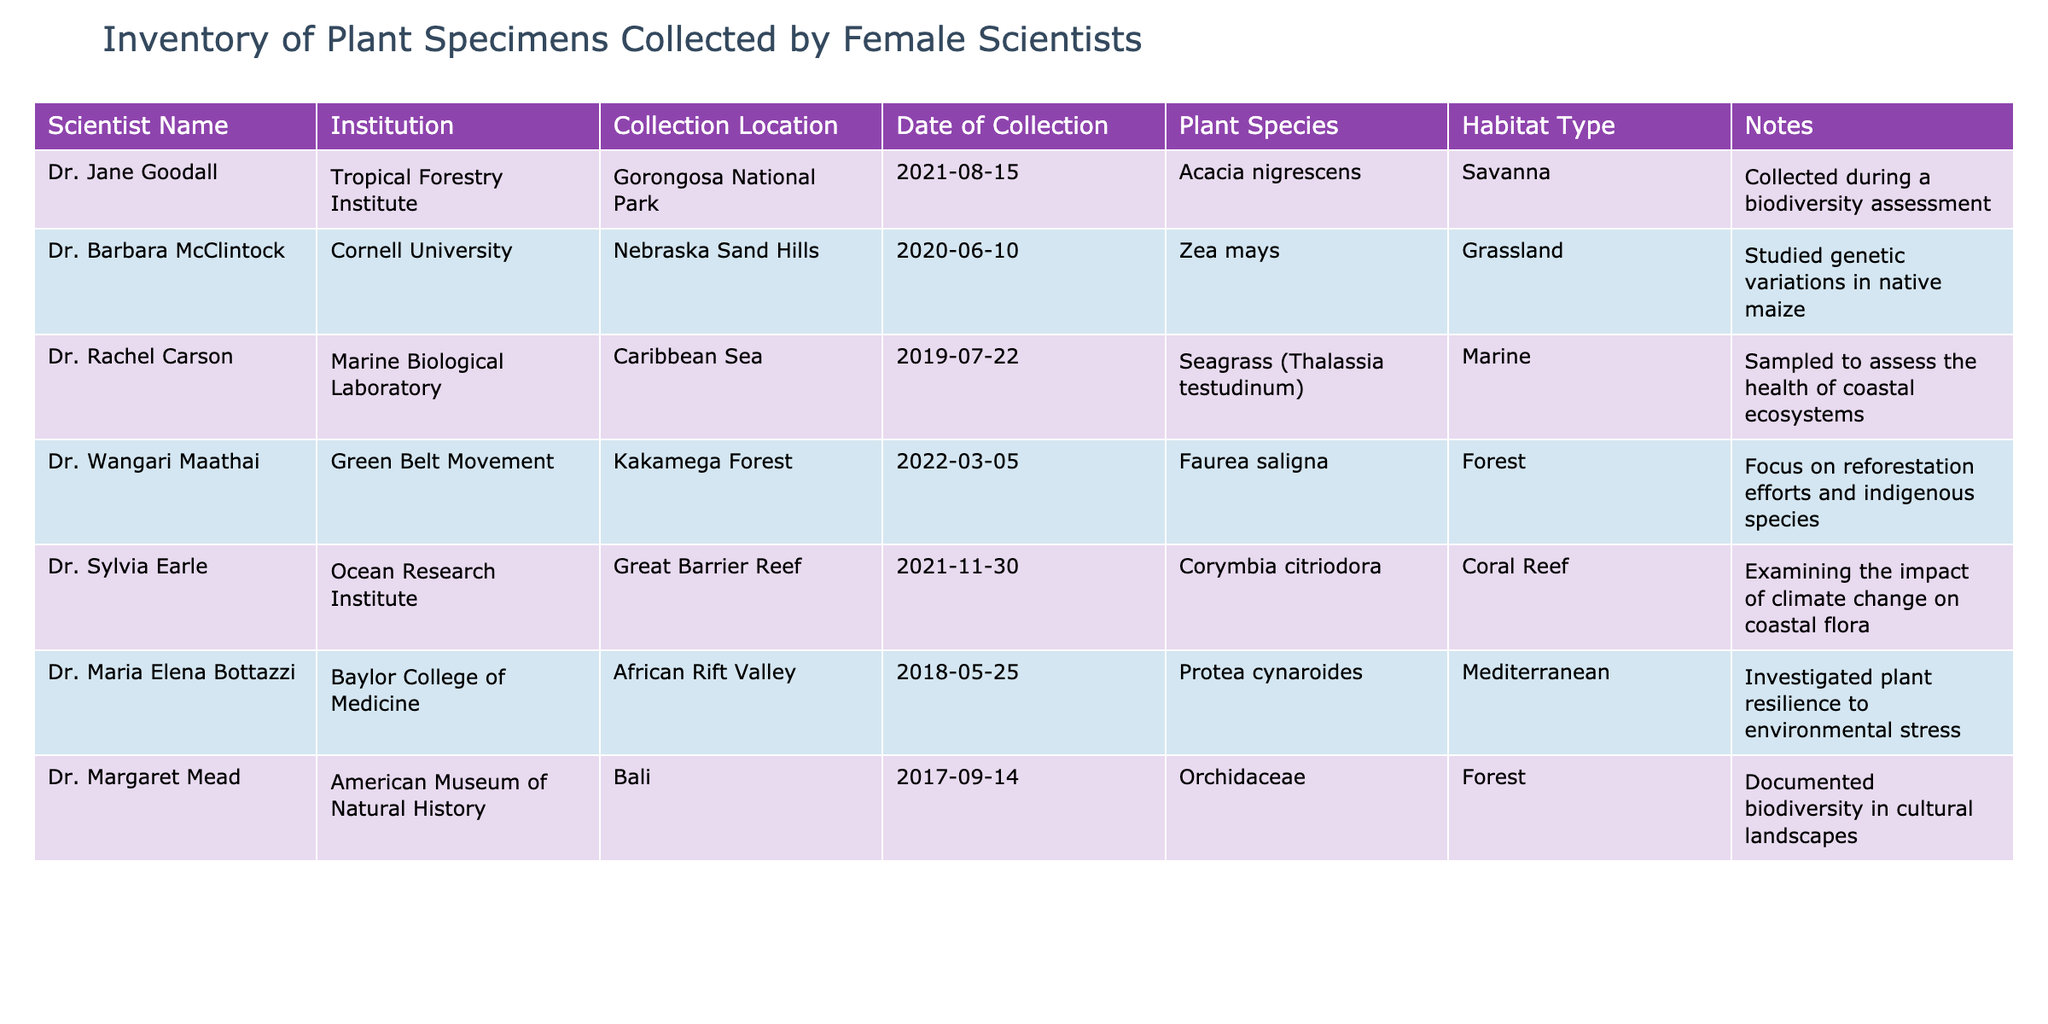What is the plant species collected by Dr. Rachel Carson? In the table, we can find Dr. Rachel Carson's entry, and it lists "Seagrass (Thalassia testudinum)" as the plant species she collected.
Answer: Seagrass (Thalassia testudinum) How many specimens were collected from forest habitats? By examining the "Habitat Type" column, we see that two entries are marked as "Forest": one from Dr. Wangari Maathai and another from Dr. Margaret Mead. Therefore, there are 2 specimens collected from forest habitats.
Answer: 2 Did Dr. Jane Goodall collect specimens in 2021? Looking at Dr. Jane Goodall's entry, the "Date of Collection" is listed as "2021-08-15", which confirms that she did collect specimens that year.
Answer: Yes Which scientist focused on climate change impact on coastal flora? Referring to the table, Dr. Sylvia Earle is the scientist who examined the impact of climate change on coastal flora, as indicated in her notes.
Answer: Dr. Sylvia Earle What is the total number of specimens collected in 2020? Checking the "Date of Collection" column, only Dr. Barbara McClintock's entry is from 2020. Since there is only one specimen from that year, the total is 1.
Answer: 1 Which collection location is associated with the plant species "Orchidaceae"? The entry for "Orchidaceae" associates it with the collection location "Bali" as stated in Dr. Margaret Mead's row in the table.
Answer: Bali What is the average year of collection for the specimens in this inventory? The years of collection span from 2017 to 2022. We can calculate the average year of collection by adding these years: (2017 + 2018 + 2019 + 2020 + 2021 + 2022) = 12107, and then dividing by the number of years, which is 6. The average year is 12107 / 6 = approximately 2019.5. Thus, rounding it, we find that the average year is around 2020.
Answer: 2020 Did Dr. Maria Elena Bottazzi collect specimens from a marine environment? By looking at the habitat type information, Dr. Maria Elena Bottazzi collected from a Mediterranean region, which is not classified as a marine environment. Thus, the answer is no.
Answer: No Which scientist's work focused on reforestation efforts? According to the table, Dr. Wangari Maathai is noted for her focus on reforestation efforts and indigenous species, as noted in her entry.
Answer: Dr. Wangari Maathai 